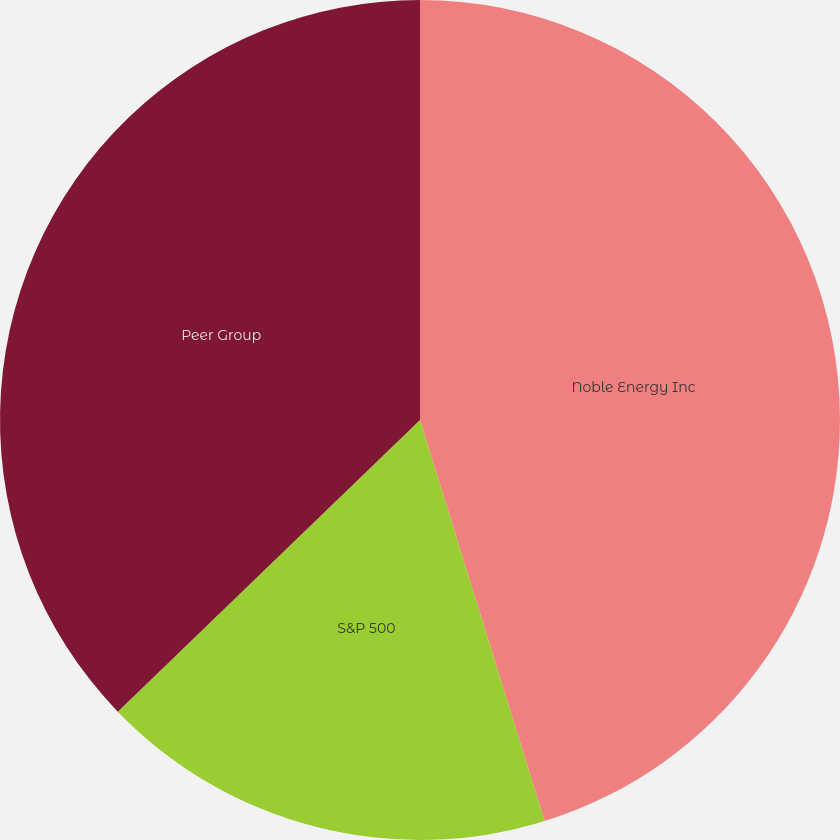Convert chart to OTSL. <chart><loc_0><loc_0><loc_500><loc_500><pie_chart><fcel>Noble Energy Inc<fcel>S&P 500<fcel>Peer Group<nl><fcel>45.21%<fcel>17.58%<fcel>37.22%<nl></chart> 